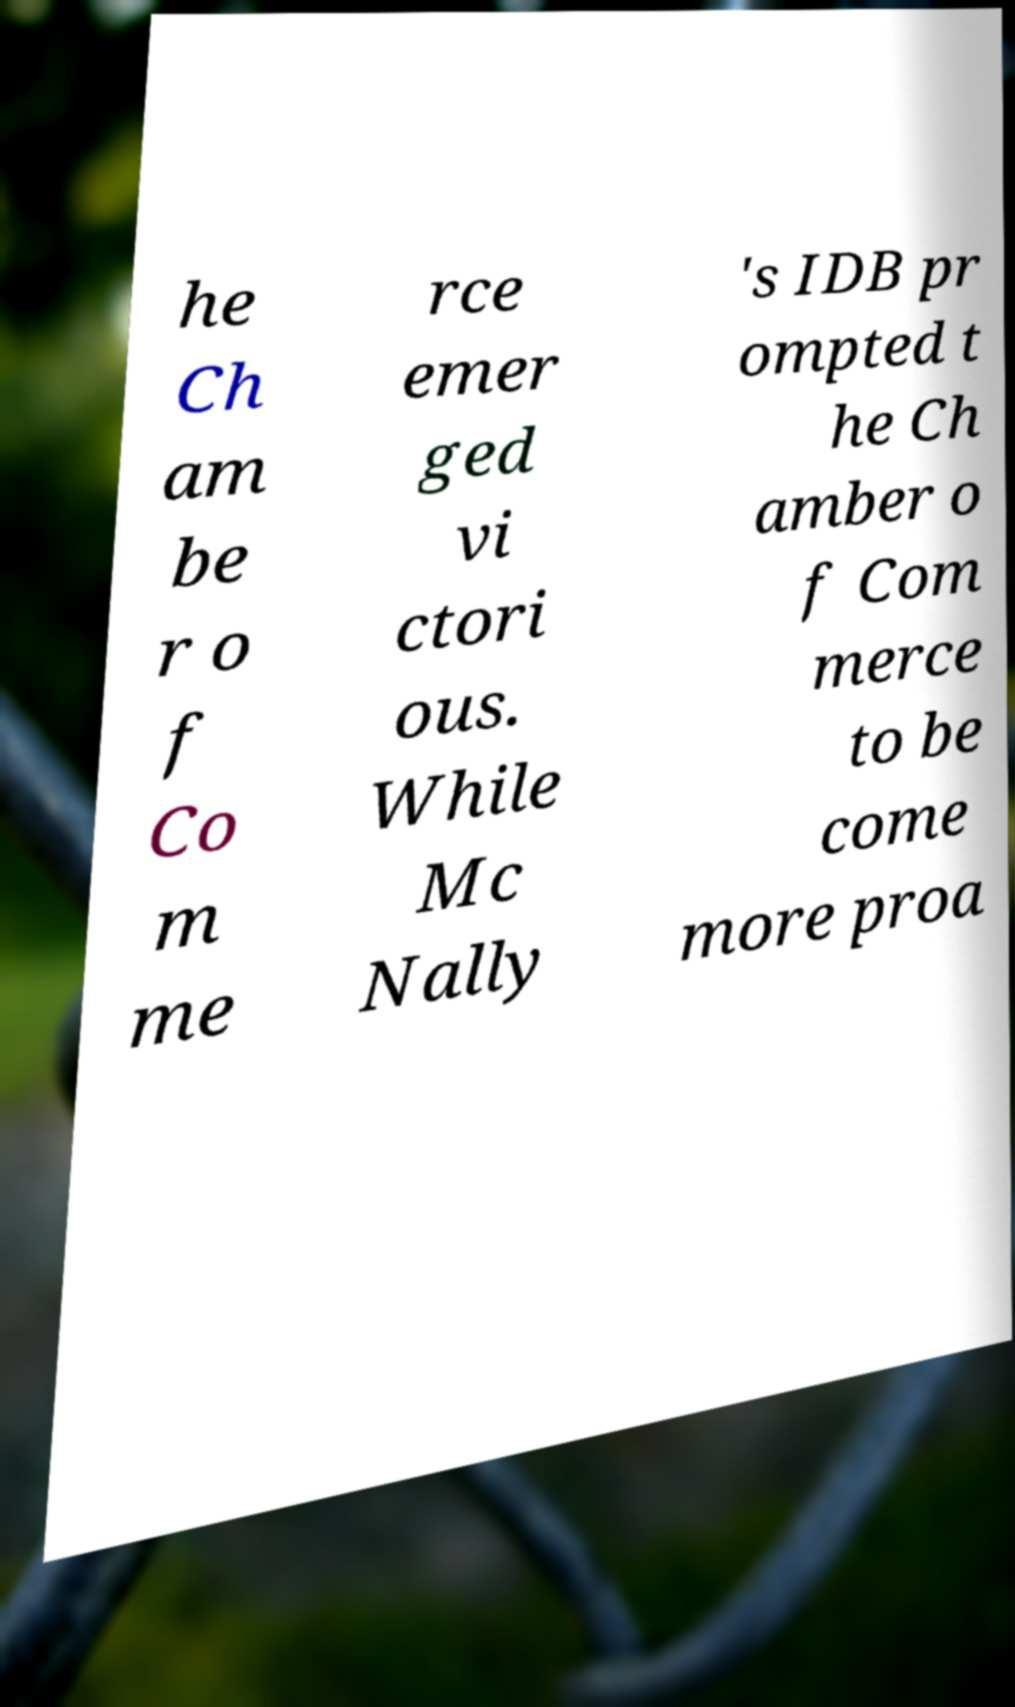For documentation purposes, I need the text within this image transcribed. Could you provide that? he Ch am be r o f Co m me rce emer ged vi ctori ous. While Mc Nally 's IDB pr ompted t he Ch amber o f Com merce to be come more proa 